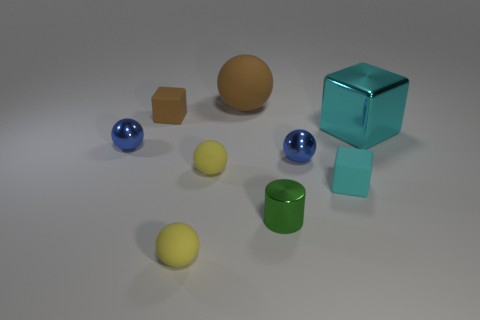Is the color of the big shiny object the same as the big ball?
Offer a terse response. No. What number of cubes are small brown matte things or metallic things?
Make the answer very short. 2. There is a cylinder that is behind the tiny sphere in front of the cyan rubber cube; what is its color?
Provide a short and direct response. Green. There is a thing that is the same color as the big sphere; what size is it?
Your response must be concise. Small. How many big shiny cubes are in front of the tiny yellow rubber sphere that is behind the shiny cylinder that is in front of the large block?
Your answer should be compact. 0. There is a blue object to the left of the tiny cylinder; is its shape the same as the tiny matte object behind the cyan metal thing?
Ensure brevity in your answer.  No. What number of things are either cyan rubber cylinders or tiny cyan things?
Your response must be concise. 1. The tiny yellow sphere that is to the left of the yellow rubber thing behind the cyan rubber block is made of what material?
Give a very brief answer. Rubber. Are there any tiny balls of the same color as the cylinder?
Your answer should be very brief. No. What is the color of the rubber ball that is the same size as the cyan shiny cube?
Your answer should be very brief. Brown. 